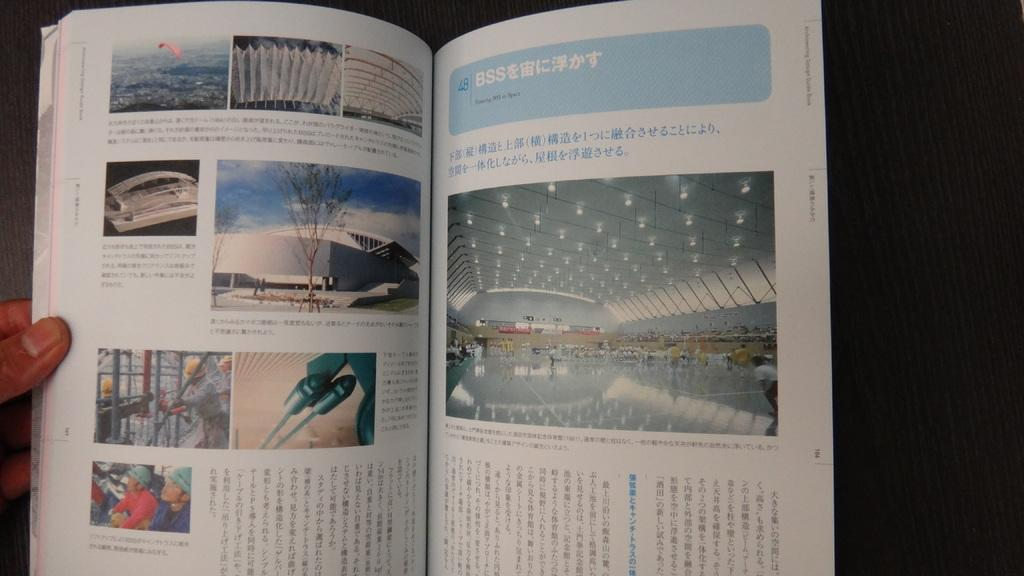Provide a one-sentence caption for the provided image. An open book with many pictures showcasing structure design and the title Floating BSS in Space on one of its pages. 